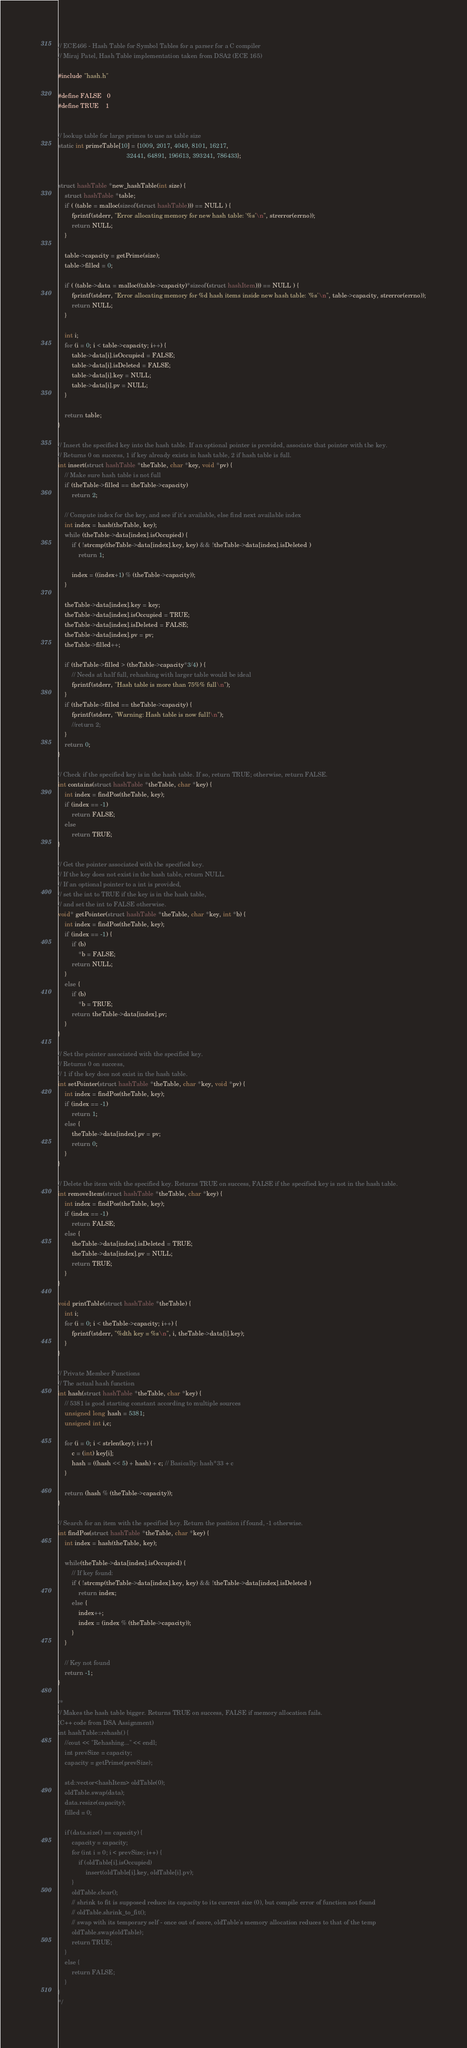Convert code to text. <code><loc_0><loc_0><loc_500><loc_500><_C_>// ECE466 - Hash Table for Symbol Tables for a parser for a C compiler
// Miraj Patel, Hash Table implementation taken from DSA2 (ECE 165)

#include "hash.h"

#define FALSE   0
#define TRUE    1


// lookup table for large primes to use as table size
static int primeTable[10] = {1009, 2017, 4049, 8101, 16217,
                                        32441, 64891, 196613, 393241, 786433};


struct hashTable *new_hashTable(int size) {
    struct hashTable *table;
    if ( (table = malloc(sizeof(struct hashTable))) == NULL ) {
        fprintf(stderr, "Error allocating memory for new hash table: '%s'\n", strerror(errno));
        return NULL;
    }
    
    table->capacity = getPrime(size);
    table->filled = 0;
    
    if ( (table->data = malloc((table->capacity)*sizeof(struct hashItem))) == NULL ) {
        fprintf(stderr, "Error allocating memory for %d hash items inside new hash table: '%s'\n", table->capacity, strerror(errno));
        return NULL;
    }
    
    int i;
    for (i = 0; i < table->capacity; i++) {
        table->data[i].isOccupied = FALSE;
        table->data[i].isDeleted = FALSE;
        table->data[i].key = NULL;
        table->data[i].pv = NULL;
    }
    
    return table;
}

// Insert the specified key into the hash table. If an optional pointer is provided, associate that pointer with the key.
// Returns 0 on success, 1 if key already exists in hash table, 2 if hash table is full.
int insert(struct hashTable *theTable, char *key, void *pv) {
    // Make sure hash table is not full
    if (theTable->filled == theTable->capacity)
        return 2;
    
    // Compute index for the key, and see if it's available, else find next available index
    int index = hash(theTable, key);
    while (theTable->data[index].isOccupied) {
        if ( !strcmp(theTable->data[index].key, key) && !theTable->data[index].isDeleted )
            return 1;
        
        index = ((index+1) % (theTable->capacity));
    }
    
    theTable->data[index].key = key;
    theTable->data[index].isOccupied = TRUE;
    theTable->data[index].isDeleted = FALSE;
    theTable->data[index].pv = pv;
    theTable->filled++;
    
    if (theTable->filled > (theTable->capacity*3/4) ) {
        // Needs at half full, rehashing with larger table would be ideal
        fprintf(stderr, "Hash table is more than 75%% full\n");
    }
    if (theTable->filled == theTable->capacity) {
        fprintf(stderr, "Warning: Hash table is now full!\n");
        //return 2;
    }
    return 0;
}

// Check if the specified key is in the hash table. If so, return TRUE; otherwise, return FALSE.
int contains(struct hashTable *theTable, char *key) {
    int index = findPos(theTable, key);
    if (index == -1)
        return FALSE;
    else
        return TRUE;
}

// Get the pointer associated with the specified key.
// If the key does not exist in the hash table, return NULL.
// If an optional pointer to a int is provided,
// set the int to TRUE if the key is in the hash table,
// and set the int to FALSE otherwise.
void* getPointer(struct hashTable *theTable, char *key, int *b) {
    int index = findPos(theTable, key);
    if (index == -1) {
        if (b)
            *b = FALSE;
        return NULL;
    }
    else {
        if (b)
            *b = TRUE;
        return theTable->data[index].pv;
    }
}

// Set the pointer associated with the specified key.
// Returns 0 on success,
// 1 if the key does not exist in the hash table.
int setPointer(struct hashTable *theTable, char *key, void *pv) {
    int index = findPos(theTable, key);
    if (index == -1) 
        return 1;
    else {
        theTable->data[index].pv = pv;
        return 0;
    }
}

// Delete the item with the specified key. Returns TRUE on success, FALSE if the specified key is not in the hash table.
int removeItem(struct hashTable *theTable, char *key) {
    int index = findPos(theTable, key);
    if (index == -1)
        return FALSE;
    else {
        theTable->data[index].isDeleted = TRUE;
        theTable->data[index].pv = NULL;
        return TRUE;
    }
}

void printTable(struct hashTable *theTable) {
    int i;
    for (i = 0; i < theTable->capacity; i++) {
        fprintf(stderr, "%dth key = %s\n", i, theTable->data[i].key);
    }
}

// Private Member Functions
// The actual hash function
int hash(struct hashTable *theTable, char *key) {
    // 5381 is good starting constant according to multiple sources
    unsigned long hash = 5381;
    unsigned int i,c;
    
    for (i = 0; i < strlen(key); i++) {
        c = (int) key[i];
        hash = ((hash << 5) + hash) + c; // Basically: hash*33 + c
    }
    
    return (hash % (theTable->capacity));
}

// Search for an item with the specified key. Return the position if found, -1 otherwise.
int findPos(struct hashTable *theTable, char *key) {
    int index = hash(theTable, key);
    
    while(theTable->data[index].isOccupied) {
        // If key found:
        if ( !strcmp(theTable->data[index].key, key) && !theTable->data[index].isDeleted )
            return index;
        else {
            index++;
            index = (index % (theTable->capacity));
        }
    }
    
    // Key not found
    return -1;
}

/*
// Makes the hash table bigger. Returns TRUE on success, FALSE if memory allocation fails.
(C++ code from DSA Assignment)
int hashTable::rehash() {
    //cout << "Rehashing..." << endl;
    int prevSize = capacity;
    capacity = getPrime(prevSize);
    
    std::vector<hashItem> oldTable(0);
    oldTable.swap(data);
    data.resize(capacity);
    filled = 0;
    
    if (data.size() == capacity) {
        capacity = capacity;
        for (int i = 0; i < prevSize; i++) {
            if (oldTable[i].isOccupied)
                insert(oldTable[i].key, oldTable[i].pv);
        }
        oldTable.clear();
        // shrink to fit is supposed reduce its capacity to its current size (0), but compile error of function not found
        // oldTable.shrink_to_fit();
        // swap with its temporary self - once out of score, oldTable's memory allocation reduces to that of the temp
        oldTable.swap(oldTable);
        return TRUE;
    }
    else {
        return FALSE;
    }
}
*/

</code> 